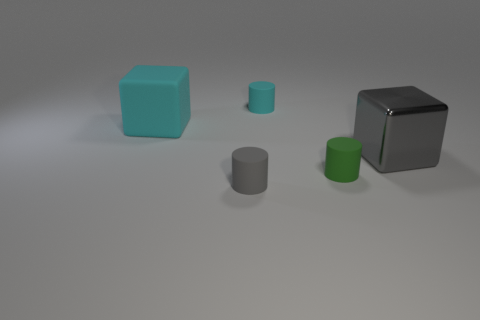The other matte object that is the same color as the big matte thing is what shape?
Your answer should be compact. Cylinder. Are any green objects visible?
Your response must be concise. Yes. Does the large matte cube have the same color as the big metallic block?
Your answer should be compact. No. How many large objects are either gray matte objects or green matte cylinders?
Ensure brevity in your answer.  0. Are there any other things that have the same color as the shiny block?
Offer a terse response. Yes. There is a large cyan object that is made of the same material as the green cylinder; what is its shape?
Your answer should be very brief. Cube. What is the size of the block that is left of the tiny cyan thing?
Your answer should be compact. Large. What is the shape of the large gray thing?
Your answer should be very brief. Cube. There is a cube that is left of the small gray rubber cylinder; is its size the same as the gray object behind the gray rubber cylinder?
Ensure brevity in your answer.  Yes. There is a cyan matte object that is to the left of the gray object in front of the large block right of the green cylinder; what size is it?
Give a very brief answer. Large. 